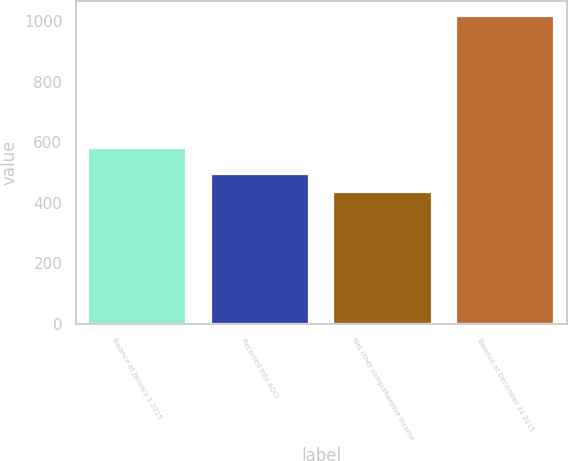<chart> <loc_0><loc_0><loc_500><loc_500><bar_chart><fcel>Balance at January 1 2015<fcel>Recorded into AOCI<fcel>Net other comprehensive income<fcel>Balance at December 31 2015<nl><fcel>579.8<fcel>495.18<fcel>437.2<fcel>1017<nl></chart> 